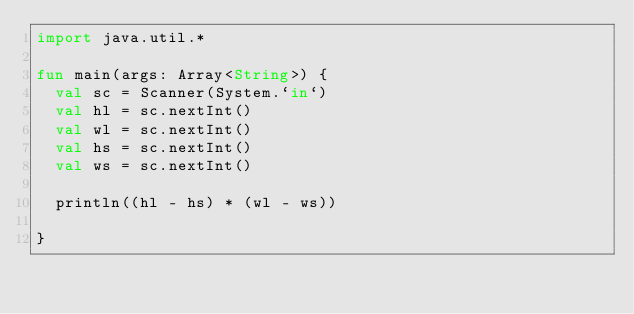Convert code to text. <code><loc_0><loc_0><loc_500><loc_500><_Kotlin_>import java.util.*

fun main(args: Array<String>) {
  val sc = Scanner(System.`in`)
  val hl = sc.nextInt()
  val wl = sc.nextInt()
  val hs = sc.nextInt()
  val ws = sc.nextInt()

  println((hl - hs) * (wl - ws))

}
</code> 